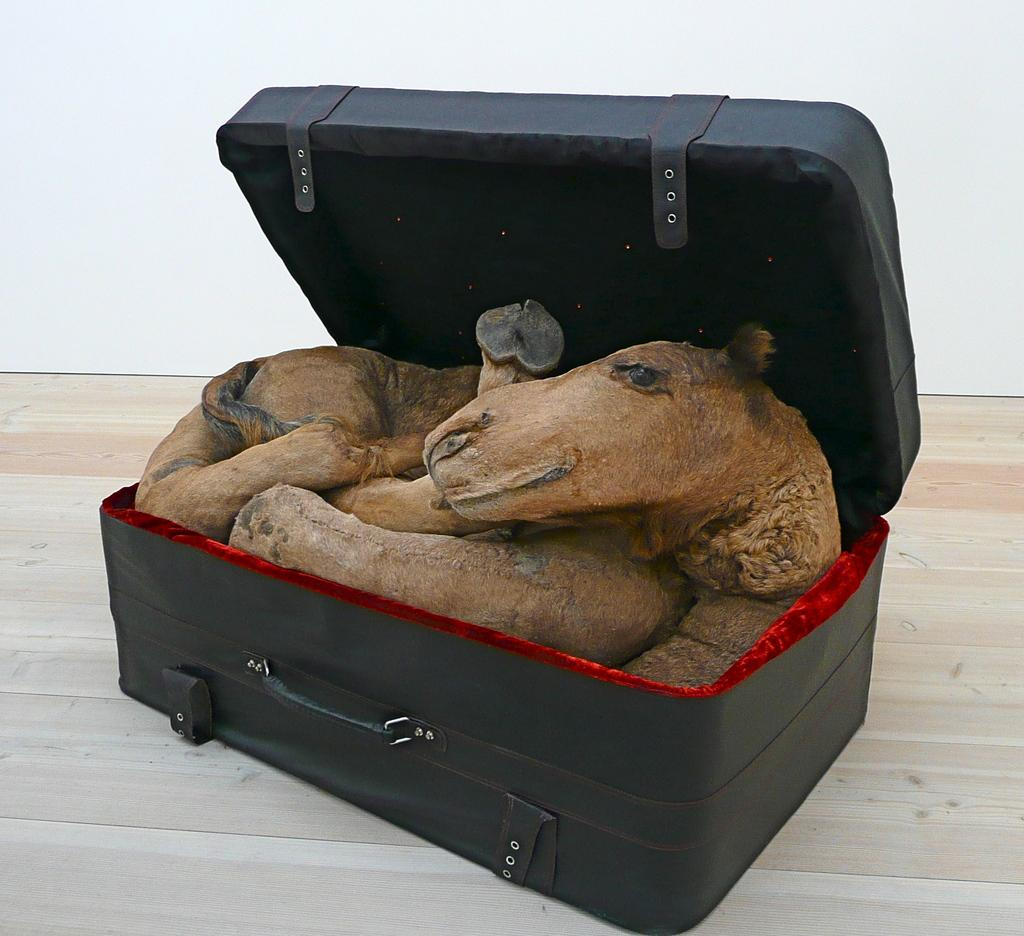What color is the suitcase in the image? The suitcase in the image is black. What is inside the suitcase? A toy is stuffed in the suitcase. What type of teaching method is being demonstrated in the image? There is no teaching method or activity depicted in the image; it features a black suitcase with a toy inside. 